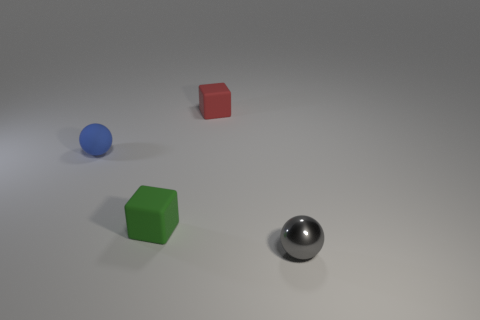Do the blue rubber sphere and the gray ball have the same size?
Provide a short and direct response. Yes. What color is the small sphere that is to the left of the ball right of the tiny matte block behind the small blue matte thing?
Ensure brevity in your answer.  Blue. What number of tiny metallic spheres are the same color as the rubber sphere?
Your answer should be very brief. 0. What number of small things are red rubber blocks or metal objects?
Provide a succinct answer. 2. Are there any tiny green objects that have the same shape as the red thing?
Your answer should be compact. Yes. Is the shape of the small blue matte object the same as the tiny metal thing?
Ensure brevity in your answer.  Yes. The tiny thing that is behind the sphere behind the small gray ball is what color?
Make the answer very short. Red. What color is the sphere that is the same size as the metal thing?
Provide a short and direct response. Blue. How many rubber objects are either small red cylinders or gray things?
Your answer should be compact. 0. What number of things are to the left of the rubber block that is in front of the small blue sphere?
Your answer should be very brief. 1. 